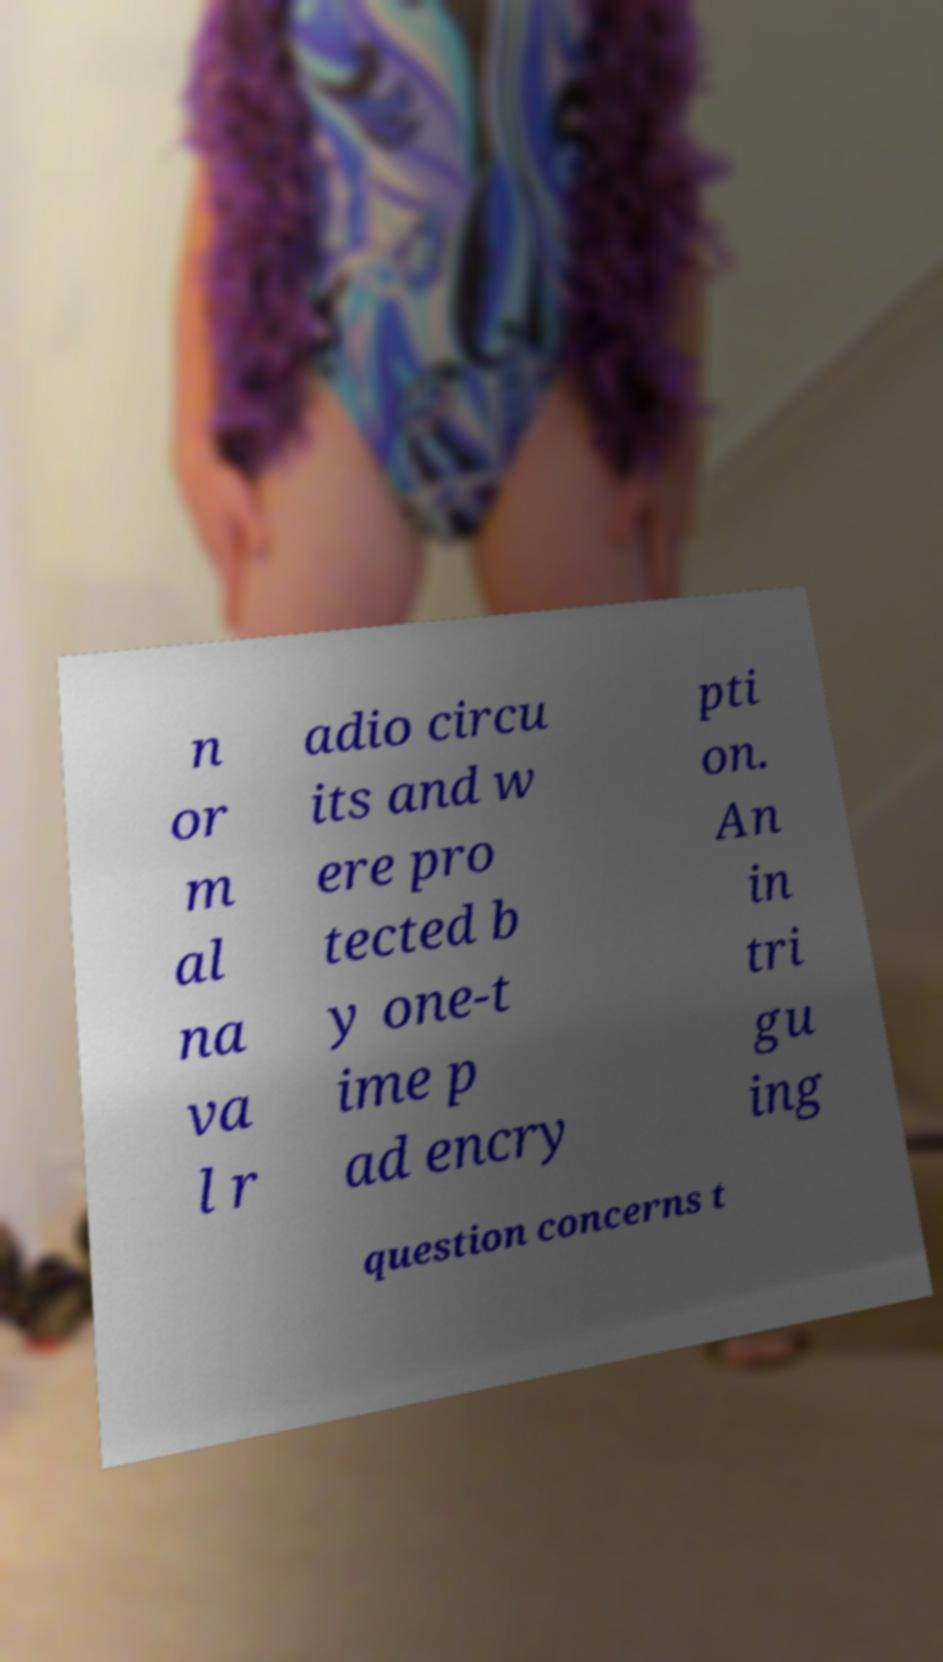Can you accurately transcribe the text from the provided image for me? n or m al na va l r adio circu its and w ere pro tected b y one-t ime p ad encry pti on. An in tri gu ing question concerns t 